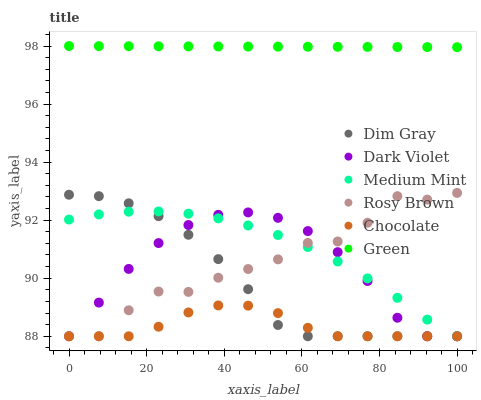Does Chocolate have the minimum area under the curve?
Answer yes or no. Yes. Does Green have the maximum area under the curve?
Answer yes or no. Yes. Does Dim Gray have the minimum area under the curve?
Answer yes or no. No. Does Dim Gray have the maximum area under the curve?
Answer yes or no. No. Is Green the smoothest?
Answer yes or no. Yes. Is Rosy Brown the roughest?
Answer yes or no. Yes. Is Dim Gray the smoothest?
Answer yes or no. No. Is Dim Gray the roughest?
Answer yes or no. No. Does Medium Mint have the lowest value?
Answer yes or no. Yes. Does Green have the lowest value?
Answer yes or no. No. Does Green have the highest value?
Answer yes or no. Yes. Does Dim Gray have the highest value?
Answer yes or no. No. Is Rosy Brown less than Green?
Answer yes or no. Yes. Is Green greater than Dim Gray?
Answer yes or no. Yes. Does Chocolate intersect Dark Violet?
Answer yes or no. Yes. Is Chocolate less than Dark Violet?
Answer yes or no. No. Is Chocolate greater than Dark Violet?
Answer yes or no. No. Does Rosy Brown intersect Green?
Answer yes or no. No. 